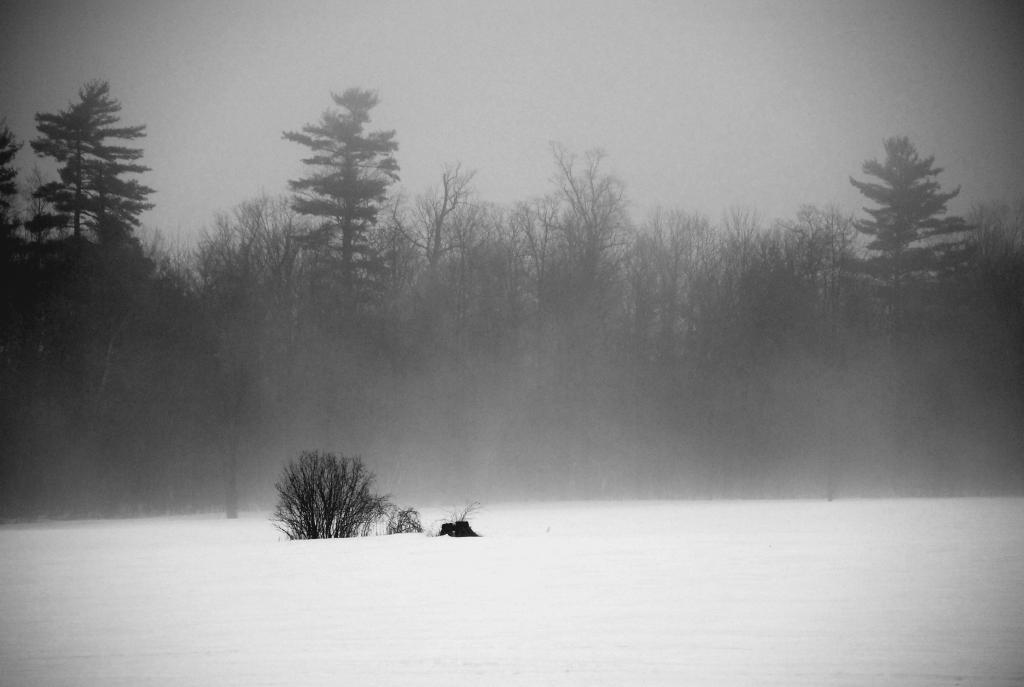What is located in the center of the image? There are trees in the center of the image. What is the ground made of in the image? The trees are on snow. What can be seen in the background of the image? There is sky visible in the background of the image. What type of vegetation is present at the bottom of the image? Plants are present at the bottom of the image. What is the condition of the ground at the bottom of the image? Snow is visible at the bottom of the image. What type of yak is participating in the competition in the image? There is no yak or competition present in the image. How is the steam generated in the image? There is no steam present in the image. 